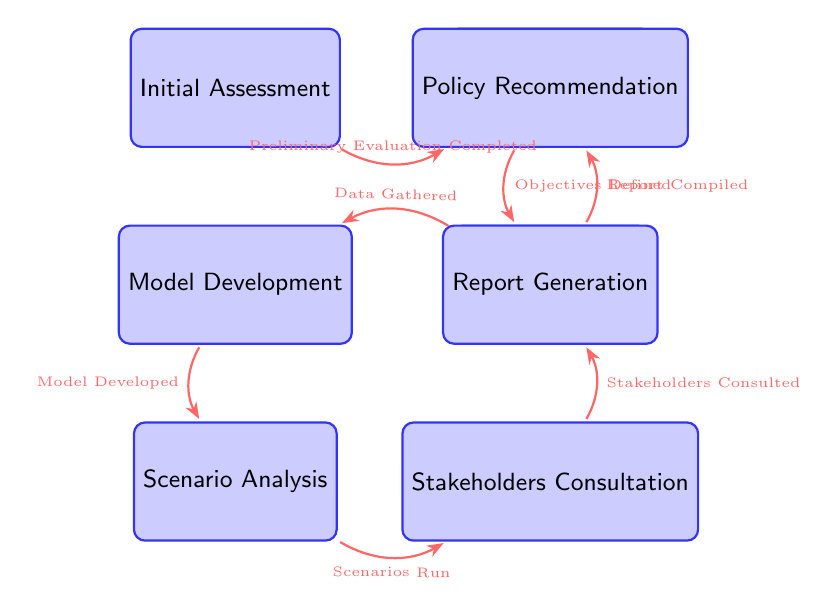What is the first state in the workflow? The first state in the workflow is identified as "Initial Assessment," which is located at the top left of the diagram.
Answer: Initial Assessment How many states are there in total? By counting each node in the diagram, there are a total of eight distinct states ranging from "Initial Assessment" to "Policy Recommendation."
Answer: 8 Which state follows "Data Collection"? The state that directly follows "Data Collection" is "Model Development," as indicated by the arrow connecting these two nodes in the diagram.
Answer: Model Development What is the trigger for transitioning from "Stakeholders Consultation" to "Report Generation"? The trigger for this transition is labeled as "Stakeholders Consulted," which is noted on the arrow connecting these two states in the diagram.
Answer: Stakeholders Consulted Which state precedes "Scenario Analysis"? The state that comes before "Scenario Analysis" is "Model Development," indicated by the directional arrow pointing from "Model Development" to "Scenario Analysis."
Answer: Model Development How many transitions are present in the workflow? The number of transitions can be determined by counting the arrows connecting the states; there are a total of seven transitions in this diagram.
Answer: 7 What is the final state in the workflow? The last state in the workflow sequence is identified as "Policy Recommendation," which is at the top of the final column on the right side of the diagram.
Answer: Policy Recommendation Which state has a transition triggered by "Data Gathered"? The state that has a transition triggered by "Data Gathered" is "Model Development," as illustrated by the arrow leading from "Data Collection" to "Model Development."
Answer: Model Development What does the workflow analyze the impact of? The workflow specifically analyzes the fiscal impact of increased funding for early childhood education programs, as inferred from the context and titles of the states involved.
Answer: Increased funding for ECE programs 